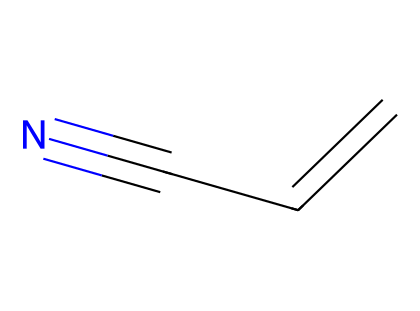What is the name of this chemical? The molecule represented by the SMILES is acrylonitrile, which is identified by its specific combination of carbon and nitrogen atoms and the unsaturation in its structure (the carbon-carbon double bond and the nitrile group).
Answer: acrylonitrile How many carbon atoms are in this molecule? By analyzing the SMILES, we can count the number of carbon (C) atoms represented. The structure shows three carbon atoms connected with one forming a double bond and one nitrogen atom.
Answer: 3 What functional group is present in acrylonitrile? In the SMILES representation, we see a "C#N" arrangement, which indicates the presence of a nitrile functional group, characterized by a carbon triple-bonded to a nitrogen atom.
Answer: nitrile How many bonds are formed in total between carbon atoms? The SMILES indicates a carbon-carbon double bond (1 bond) and a single bond between the terminal carbon and the other carbon, leading to a total of 2 carbon-carbon bonds within the molecule.
Answer: 2 What type of chemical is acrylonitrile classified as? The presence of a nitrile group confirms that acrylonitrile belongs to the class of nitriles, which are characterized by the carbon-nitrogen triple bond, as defined in organic chemistry.
Answer: nitrile What is the significance of acrylonitrile in industry? Acrylonitrile is primarily significant as a key monomer in the production of synthetic rubber and other polymer materials, which utilize its reactive unsaturation for polymerization processes.
Answer: synthetic rubber 